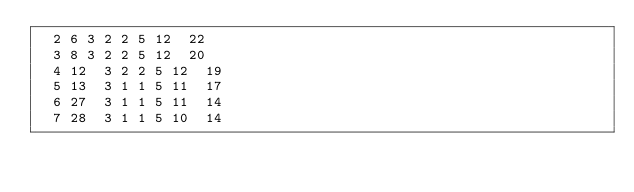<code> <loc_0><loc_0><loc_500><loc_500><_ObjectiveC_>	2	6	3	2	2	5	12	22	
	3	8	3	2	2	5	12	20	
	4	12	3	2	2	5	12	19	
	5	13	3	1	1	5	11	17	
	6	27	3	1	1	5	11	14	
	7	28	3	1	1	5	10	14	</code> 